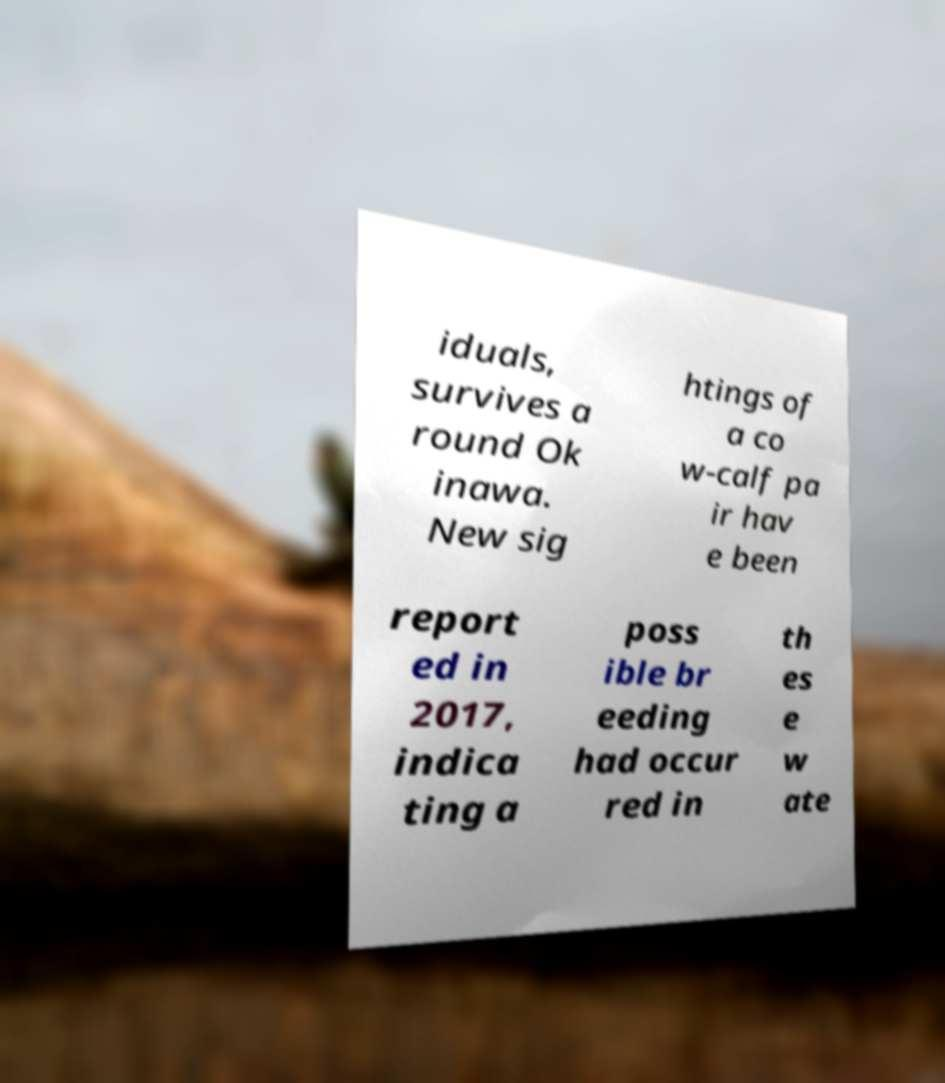Could you extract and type out the text from this image? iduals, survives a round Ok inawa. New sig htings of a co w-calf pa ir hav e been report ed in 2017, indica ting a poss ible br eeding had occur red in th es e w ate 